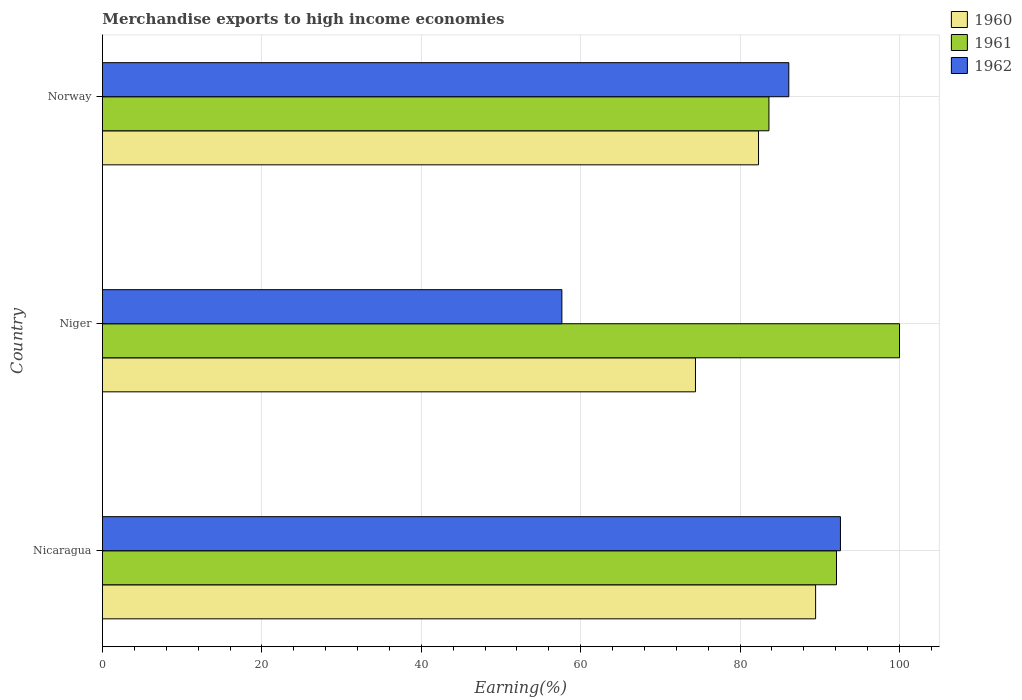How many different coloured bars are there?
Give a very brief answer. 3. How many groups of bars are there?
Your answer should be compact. 3. Are the number of bars per tick equal to the number of legend labels?
Give a very brief answer. Yes. How many bars are there on the 3rd tick from the top?
Ensure brevity in your answer.  3. How many bars are there on the 1st tick from the bottom?
Make the answer very short. 3. What is the label of the 2nd group of bars from the top?
Give a very brief answer. Niger. What is the percentage of amount earned from merchandise exports in 1961 in Nicaragua?
Your answer should be compact. 92.09. Across all countries, what is the maximum percentage of amount earned from merchandise exports in 1960?
Provide a succinct answer. 89.47. Across all countries, what is the minimum percentage of amount earned from merchandise exports in 1960?
Offer a terse response. 74.4. In which country was the percentage of amount earned from merchandise exports in 1961 maximum?
Your answer should be compact. Niger. In which country was the percentage of amount earned from merchandise exports in 1961 minimum?
Make the answer very short. Norway. What is the total percentage of amount earned from merchandise exports in 1962 in the graph?
Provide a short and direct response. 236.34. What is the difference between the percentage of amount earned from merchandise exports in 1962 in Nicaragua and that in Niger?
Ensure brevity in your answer.  34.95. What is the difference between the percentage of amount earned from merchandise exports in 1962 in Nicaragua and the percentage of amount earned from merchandise exports in 1961 in Norway?
Make the answer very short. 8.97. What is the average percentage of amount earned from merchandise exports in 1961 per country?
Make the answer very short. 91.9. What is the difference between the percentage of amount earned from merchandise exports in 1960 and percentage of amount earned from merchandise exports in 1961 in Nicaragua?
Make the answer very short. -2.62. What is the ratio of the percentage of amount earned from merchandise exports in 1960 in Niger to that in Norway?
Keep it short and to the point. 0.9. Is the difference between the percentage of amount earned from merchandise exports in 1960 in Nicaragua and Niger greater than the difference between the percentage of amount earned from merchandise exports in 1961 in Nicaragua and Niger?
Your answer should be compact. Yes. What is the difference between the highest and the second highest percentage of amount earned from merchandise exports in 1962?
Ensure brevity in your answer.  6.48. What is the difference between the highest and the lowest percentage of amount earned from merchandise exports in 1961?
Your answer should be very brief. 16.38. Is it the case that in every country, the sum of the percentage of amount earned from merchandise exports in 1962 and percentage of amount earned from merchandise exports in 1961 is greater than the percentage of amount earned from merchandise exports in 1960?
Keep it short and to the point. Yes. How many bars are there?
Ensure brevity in your answer.  9. How many countries are there in the graph?
Provide a succinct answer. 3. How are the legend labels stacked?
Offer a terse response. Vertical. What is the title of the graph?
Your answer should be very brief. Merchandise exports to high income economies. What is the label or title of the X-axis?
Make the answer very short. Earning(%). What is the Earning(%) in 1960 in Nicaragua?
Your answer should be very brief. 89.47. What is the Earning(%) in 1961 in Nicaragua?
Offer a terse response. 92.09. What is the Earning(%) of 1962 in Nicaragua?
Provide a succinct answer. 92.59. What is the Earning(%) of 1960 in Niger?
Your answer should be very brief. 74.4. What is the Earning(%) in 1962 in Niger?
Your answer should be very brief. 57.64. What is the Earning(%) of 1960 in Norway?
Your answer should be very brief. 82.31. What is the Earning(%) of 1961 in Norway?
Make the answer very short. 83.62. What is the Earning(%) of 1962 in Norway?
Offer a terse response. 86.11. Across all countries, what is the maximum Earning(%) of 1960?
Offer a terse response. 89.47. Across all countries, what is the maximum Earning(%) of 1962?
Ensure brevity in your answer.  92.59. Across all countries, what is the minimum Earning(%) in 1960?
Make the answer very short. 74.4. Across all countries, what is the minimum Earning(%) in 1961?
Your answer should be compact. 83.62. Across all countries, what is the minimum Earning(%) in 1962?
Your response must be concise. 57.64. What is the total Earning(%) in 1960 in the graph?
Give a very brief answer. 246.19. What is the total Earning(%) of 1961 in the graph?
Ensure brevity in your answer.  275.71. What is the total Earning(%) in 1962 in the graph?
Your answer should be very brief. 236.34. What is the difference between the Earning(%) in 1960 in Nicaragua and that in Niger?
Your answer should be very brief. 15.07. What is the difference between the Earning(%) of 1961 in Nicaragua and that in Niger?
Make the answer very short. -7.91. What is the difference between the Earning(%) in 1962 in Nicaragua and that in Niger?
Offer a very short reply. 34.95. What is the difference between the Earning(%) of 1960 in Nicaragua and that in Norway?
Make the answer very short. 7.16. What is the difference between the Earning(%) of 1961 in Nicaragua and that in Norway?
Offer a very short reply. 8.48. What is the difference between the Earning(%) of 1962 in Nicaragua and that in Norway?
Make the answer very short. 6.48. What is the difference between the Earning(%) of 1960 in Niger and that in Norway?
Offer a very short reply. -7.91. What is the difference between the Earning(%) in 1961 in Niger and that in Norway?
Provide a short and direct response. 16.38. What is the difference between the Earning(%) of 1962 in Niger and that in Norway?
Keep it short and to the point. -28.47. What is the difference between the Earning(%) in 1960 in Nicaragua and the Earning(%) in 1961 in Niger?
Your response must be concise. -10.53. What is the difference between the Earning(%) in 1960 in Nicaragua and the Earning(%) in 1962 in Niger?
Offer a very short reply. 31.83. What is the difference between the Earning(%) of 1961 in Nicaragua and the Earning(%) of 1962 in Niger?
Provide a short and direct response. 34.45. What is the difference between the Earning(%) in 1960 in Nicaragua and the Earning(%) in 1961 in Norway?
Your answer should be very brief. 5.86. What is the difference between the Earning(%) in 1960 in Nicaragua and the Earning(%) in 1962 in Norway?
Offer a very short reply. 3.36. What is the difference between the Earning(%) in 1961 in Nicaragua and the Earning(%) in 1962 in Norway?
Make the answer very short. 5.98. What is the difference between the Earning(%) of 1960 in Niger and the Earning(%) of 1961 in Norway?
Make the answer very short. -9.22. What is the difference between the Earning(%) in 1960 in Niger and the Earning(%) in 1962 in Norway?
Offer a terse response. -11.71. What is the difference between the Earning(%) of 1961 in Niger and the Earning(%) of 1962 in Norway?
Provide a short and direct response. 13.89. What is the average Earning(%) of 1960 per country?
Your answer should be compact. 82.06. What is the average Earning(%) in 1961 per country?
Your answer should be compact. 91.9. What is the average Earning(%) in 1962 per country?
Your answer should be compact. 78.78. What is the difference between the Earning(%) in 1960 and Earning(%) in 1961 in Nicaragua?
Provide a succinct answer. -2.62. What is the difference between the Earning(%) in 1960 and Earning(%) in 1962 in Nicaragua?
Give a very brief answer. -3.11. What is the difference between the Earning(%) of 1961 and Earning(%) of 1962 in Nicaragua?
Provide a short and direct response. -0.49. What is the difference between the Earning(%) in 1960 and Earning(%) in 1961 in Niger?
Your response must be concise. -25.6. What is the difference between the Earning(%) of 1960 and Earning(%) of 1962 in Niger?
Offer a very short reply. 16.76. What is the difference between the Earning(%) in 1961 and Earning(%) in 1962 in Niger?
Ensure brevity in your answer.  42.36. What is the difference between the Earning(%) of 1960 and Earning(%) of 1961 in Norway?
Your response must be concise. -1.3. What is the difference between the Earning(%) in 1960 and Earning(%) in 1962 in Norway?
Provide a short and direct response. -3.8. What is the difference between the Earning(%) of 1961 and Earning(%) of 1962 in Norway?
Offer a terse response. -2.49. What is the ratio of the Earning(%) of 1960 in Nicaragua to that in Niger?
Your response must be concise. 1.2. What is the ratio of the Earning(%) of 1961 in Nicaragua to that in Niger?
Provide a succinct answer. 0.92. What is the ratio of the Earning(%) of 1962 in Nicaragua to that in Niger?
Provide a short and direct response. 1.61. What is the ratio of the Earning(%) in 1960 in Nicaragua to that in Norway?
Your answer should be compact. 1.09. What is the ratio of the Earning(%) in 1961 in Nicaragua to that in Norway?
Your answer should be very brief. 1.1. What is the ratio of the Earning(%) in 1962 in Nicaragua to that in Norway?
Make the answer very short. 1.08. What is the ratio of the Earning(%) in 1960 in Niger to that in Norway?
Your answer should be compact. 0.9. What is the ratio of the Earning(%) of 1961 in Niger to that in Norway?
Provide a succinct answer. 1.2. What is the ratio of the Earning(%) in 1962 in Niger to that in Norway?
Provide a succinct answer. 0.67. What is the difference between the highest and the second highest Earning(%) in 1960?
Keep it short and to the point. 7.16. What is the difference between the highest and the second highest Earning(%) of 1961?
Ensure brevity in your answer.  7.91. What is the difference between the highest and the second highest Earning(%) of 1962?
Make the answer very short. 6.48. What is the difference between the highest and the lowest Earning(%) of 1960?
Your answer should be very brief. 15.07. What is the difference between the highest and the lowest Earning(%) of 1961?
Ensure brevity in your answer.  16.38. What is the difference between the highest and the lowest Earning(%) in 1962?
Your answer should be very brief. 34.95. 